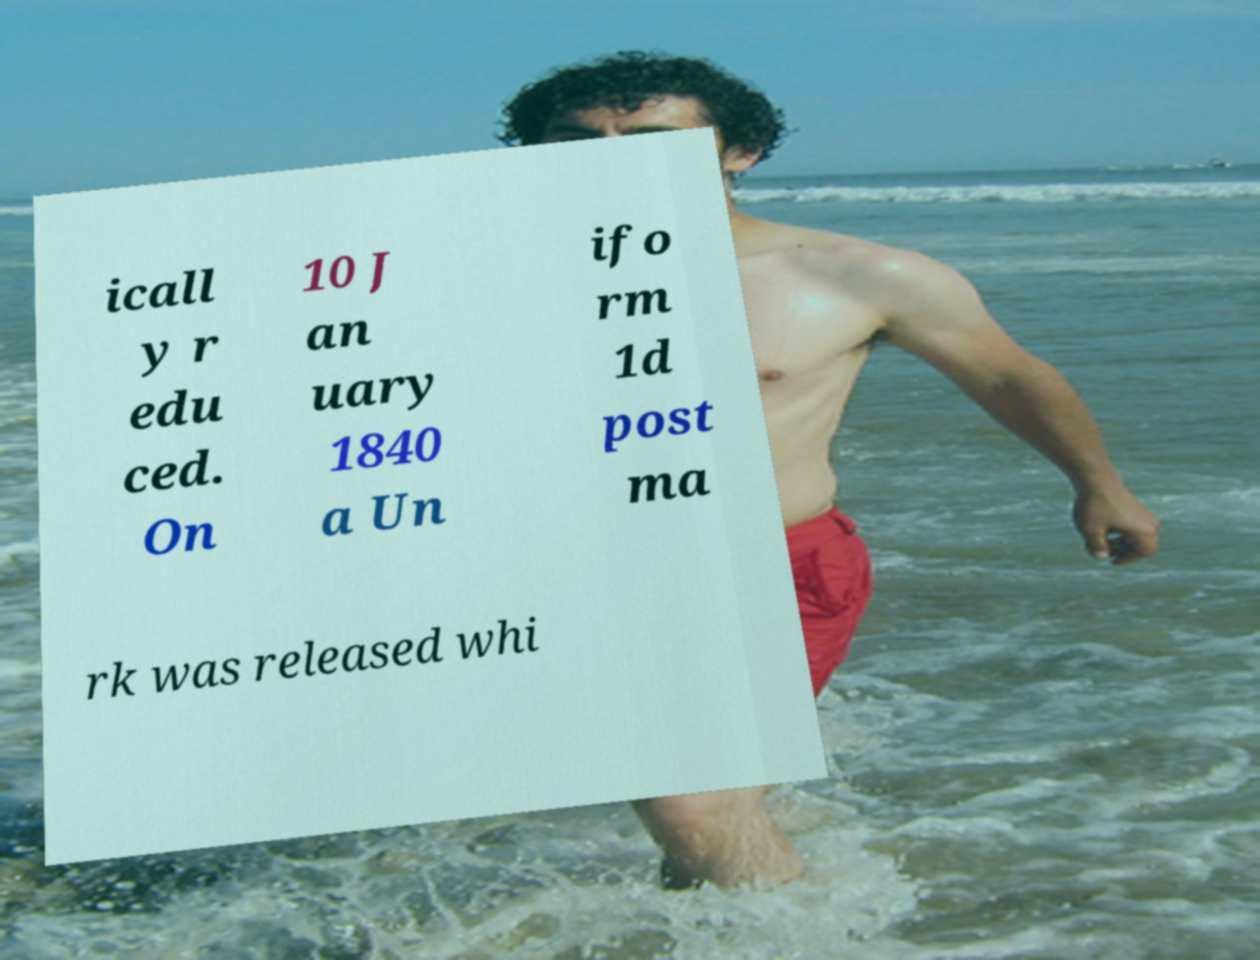Can you accurately transcribe the text from the provided image for me? icall y r edu ced. On 10 J an uary 1840 a Un ifo rm 1d post ma rk was released whi 